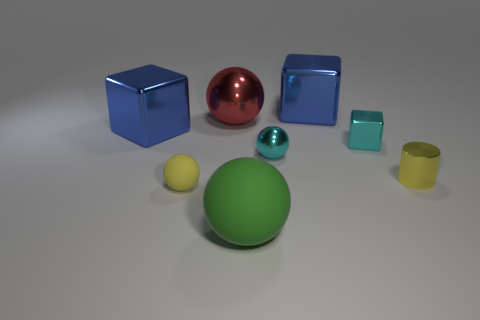Subtract all blue blocks. How many were subtracted if there are1blue blocks left? 1 Subtract all tiny blocks. How many blocks are left? 2 Subtract all cylinders. How many objects are left? 7 Subtract 1 cylinders. How many cylinders are left? 0 Subtract all green blocks. Subtract all green balls. How many blocks are left? 3 Subtract all cyan cylinders. How many purple blocks are left? 0 Subtract all large shiny objects. Subtract all red metallic things. How many objects are left? 4 Add 8 tiny metal blocks. How many tiny metal blocks are left? 9 Add 4 tiny objects. How many tiny objects exist? 8 Add 2 yellow matte things. How many objects exist? 10 